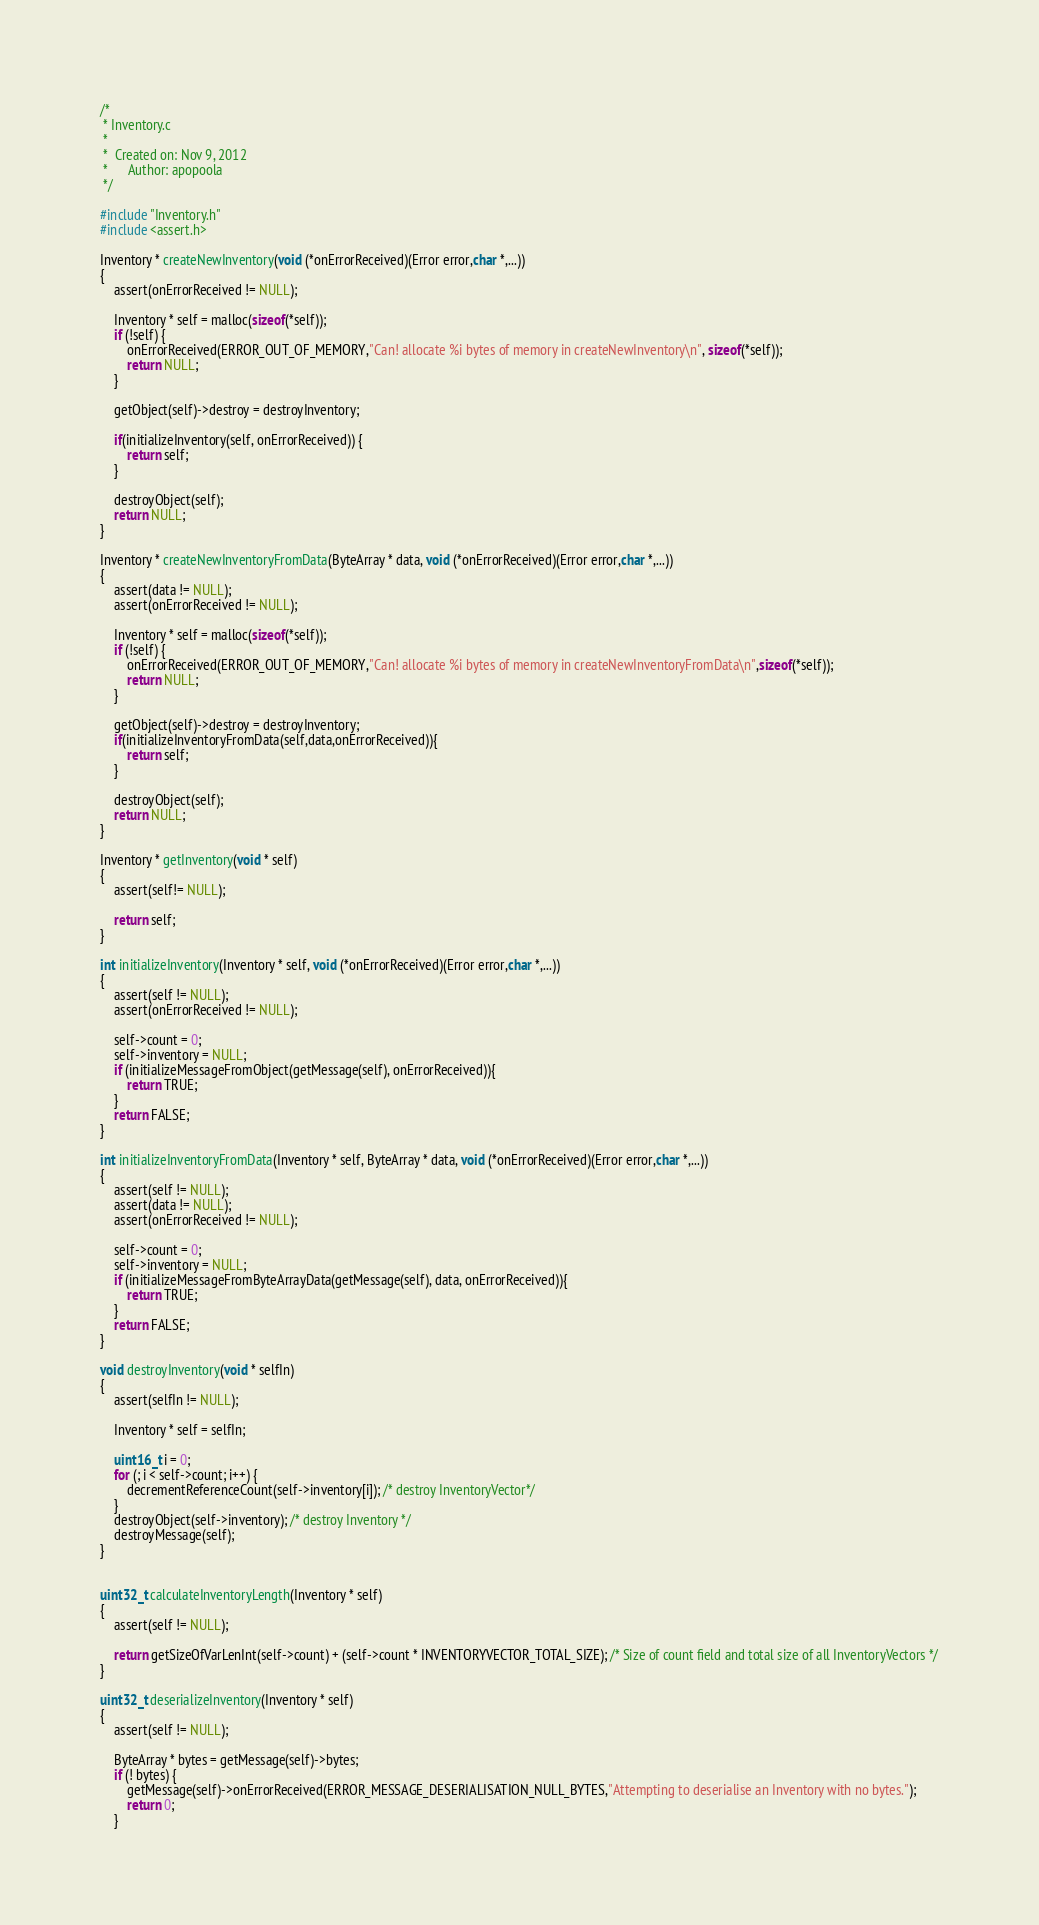Convert code to text. <code><loc_0><loc_0><loc_500><loc_500><_C_>/*
 * Inventory.c
 *
 *  Created on: Nov 9, 2012
 *      Author: apopoola
 */

#include "Inventory.h"
#include <assert.h>

Inventory * createNewInventory(void (*onErrorReceived)(Error error,char *,...))
{
	assert(onErrorReceived != NULL);

	Inventory * self = malloc(sizeof(*self));
	if (!self) {
		onErrorReceived(ERROR_OUT_OF_MEMORY,"Can! allocate %i bytes of memory in createNewInventory\n", sizeof(*self));
		return NULL;
	}

	getObject(self)->destroy = destroyInventory;

	if(initializeInventory(self, onErrorReceived)) {
		return self;
	}

	destroyObject(self);
	return NULL;
}

Inventory * createNewInventoryFromData(ByteArray * data, void (*onErrorReceived)(Error error,char *,...))
{
	assert(data != NULL);
	assert(onErrorReceived != NULL);

	Inventory * self = malloc(sizeof(*self));
	if (!self) {
		onErrorReceived(ERROR_OUT_OF_MEMORY,"Can! allocate %i bytes of memory in createNewInventoryFromData\n",sizeof(*self));
		return NULL;
	}

	getObject(self)->destroy = destroyInventory;
	if(initializeInventoryFromData(self,data,onErrorReceived)){
		return self;
	}

	destroyObject(self);
	return NULL;
}

Inventory * getInventory(void * self)
{
	assert(self!= NULL);

	return self;
}

int initializeInventory(Inventory * self, void (*onErrorReceived)(Error error,char *,...))
{
	assert(self != NULL);
	assert(onErrorReceived != NULL);

	self->count = 0;
	self->inventory = NULL;
	if (initializeMessageFromObject(getMessage(self), onErrorReceived)){
		return TRUE;
	}
	return FALSE;
}

int initializeInventoryFromData(Inventory * self, ByteArray * data, void (*onErrorReceived)(Error error,char *,...))
{
	assert(self != NULL);
	assert(data != NULL);
	assert(onErrorReceived != NULL);

	self->count = 0;
	self->inventory = NULL;
	if (initializeMessageFromByteArrayData(getMessage(self), data, onErrorReceived)){
		return TRUE;
	}
	return FALSE;
}

void destroyInventory(void * selfIn)
{
	assert(selfIn != NULL);

	Inventory * self = selfIn;

	uint16_t i = 0;
	for (; i < self->count; i++) {
		decrementReferenceCount(self->inventory[i]); /* destroy InventoryVector*/
	}
	destroyObject(self->inventory); /* destroy Inventory */
	destroyMessage(self);
}


uint32_t calculateInventoryLength(Inventory * self)
{
	assert(self != NULL);

	return getSizeOfVarLenInt(self->count) + (self->count * INVENTORYVECTOR_TOTAL_SIZE); /* Size of count field and total size of all InventoryVectors */
}

uint32_t deserializeInventory(Inventory * self)
{
	assert(self != NULL);

	ByteArray * bytes = getMessage(self)->bytes;
	if (! bytes) {
		getMessage(self)->onErrorReceived(ERROR_MESSAGE_DESERIALISATION_NULL_BYTES,"Attempting to deserialise an Inventory with no bytes.");
		return 0;
	}</code> 